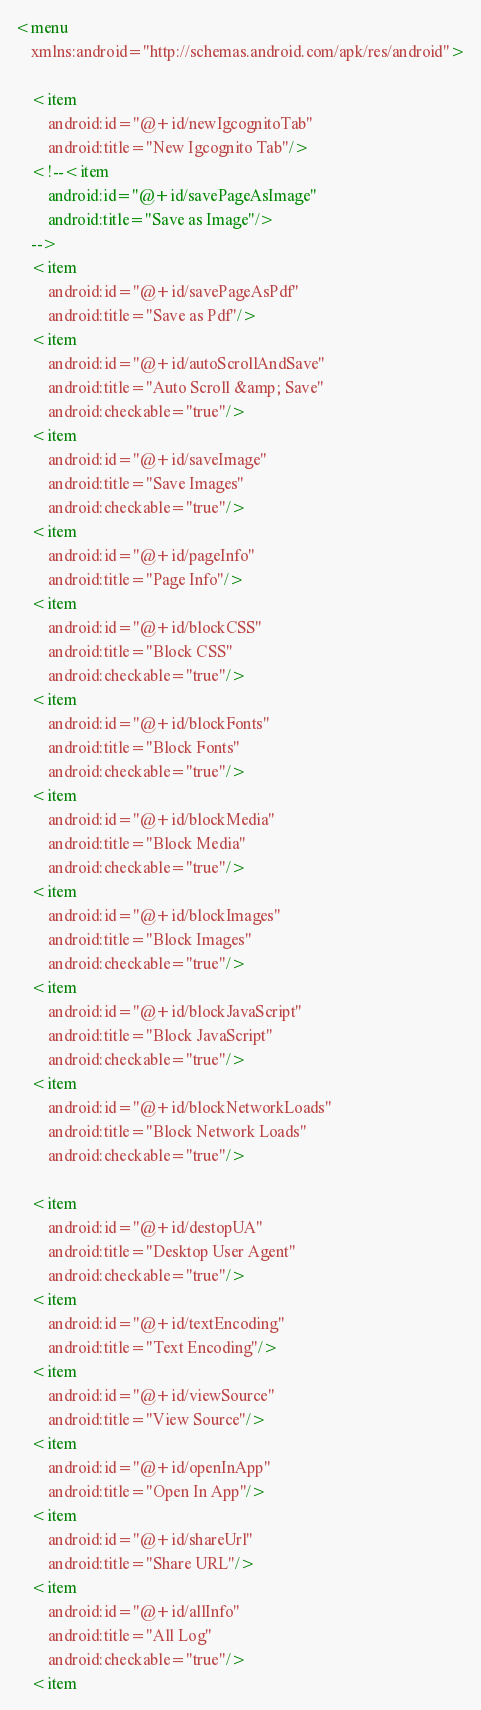<code> <loc_0><loc_0><loc_500><loc_500><_XML_><menu
	xmlns:android="http://schemas.android.com/apk/res/android">

    <item
        android:id="@+id/newIgcognitoTab"
        android:title="New Igcognito Tab"/>
    <!--<item
        android:id="@+id/savePageAsImage"
        android:title="Save as Image"/>
	-->
    <item
        android:id="@+id/savePageAsPdf"
        android:title="Save as Pdf"/>
    <item
        android:id="@+id/autoScrollAndSave"
        android:title="Auto Scroll &amp; Save"
		android:checkable="true"/>
    <item
        android:id="@+id/saveImage"
        android:title="Save Images"
		android:checkable="true"/>
    <item
        android:id="@+id/pageInfo"
        android:title="Page Info"/>
    <item
        android:id="@+id/blockCSS"
        android:title="Block CSS"
		android:checkable="true"/>
    <item
        android:id="@+id/blockFonts"
        android:title="Block Fonts"
		android:checkable="true"/>
    <item
        android:id="@+id/blockMedia"
        android:title="Block Media"
		android:checkable="true"/>
    <item
        android:id="@+id/blockImages"
        android:title="Block Images"
		android:checkable="true"/>
    <item
        android:id="@+id/blockJavaScript"
        android:title="Block JavaScript"
		android:checkable="true"/>
	<item
        android:id="@+id/blockNetworkLoads"
        android:title="Block Network Loads"
		android:checkable="true"/>
	
	<item
        android:id="@+id/destopUA"
        android:title="Desktop User Agent"
		android:checkable="true"/>
	<item
        android:id="@+id/textEncoding"
        android:title="Text Encoding"/>
	<item
        android:id="@+id/viewSource"
        android:title="View Source"/>
	<item
        android:id="@+id/openInApp"
        android:title="Open In App"/>
	<item
        android:id="@+id/shareUrl"
        android:title="Share URL"/>
    <item
        android:id="@+id/allInfo"
        android:title="All Log"
		android:checkable="true"/>
    <item</code> 